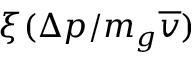<formula> <loc_0><loc_0><loc_500><loc_500>\xi ( \Delta p / m _ { g } \overline { v } )</formula> 